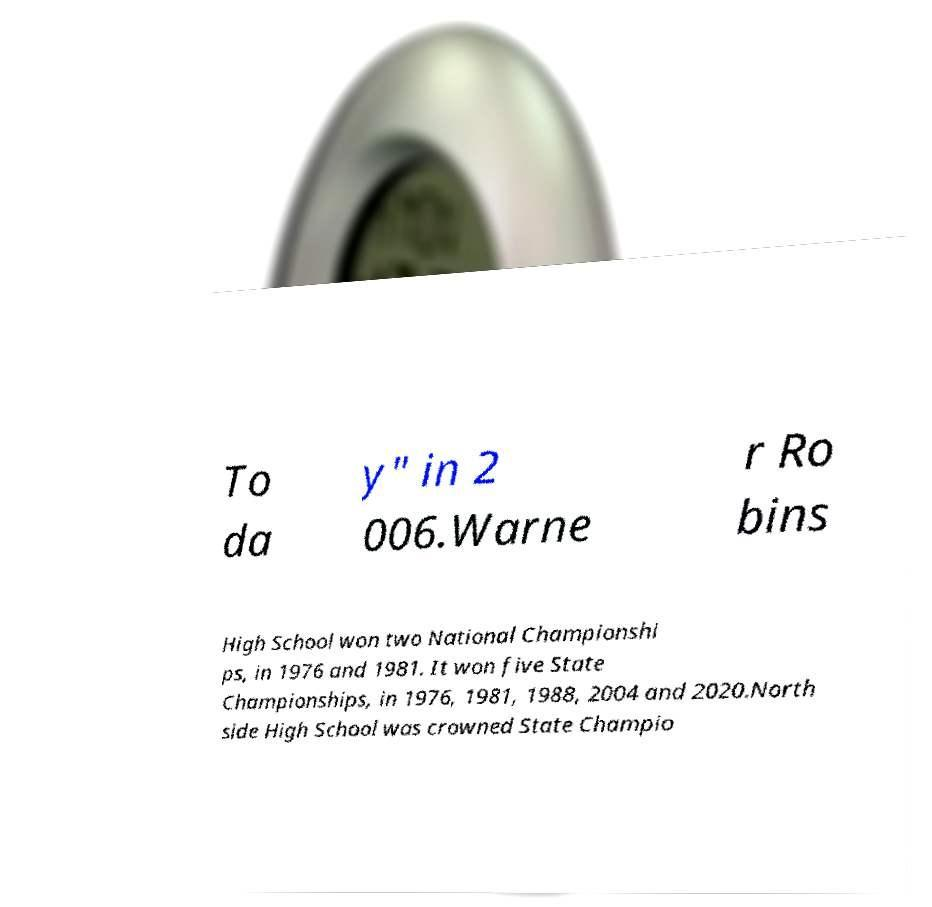I need the written content from this picture converted into text. Can you do that? To da y" in 2 006.Warne r Ro bins High School won two National Championshi ps, in 1976 and 1981. It won five State Championships, in 1976, 1981, 1988, 2004 and 2020.North side High School was crowned State Champio 